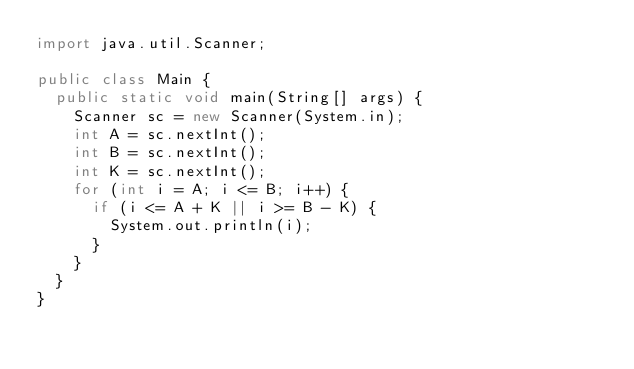Convert code to text. <code><loc_0><loc_0><loc_500><loc_500><_Java_>import java.util.Scanner;

public class Main {
	public static void main(String[] args) {
		Scanner sc = new Scanner(System.in);
		int A = sc.nextInt();
		int B = sc.nextInt();
		int K = sc.nextInt();
		for (int i = A; i <= B; i++) {
			if (i <= A + K || i >= B - K) {
				System.out.println(i);
			}
		}
	}
}</code> 